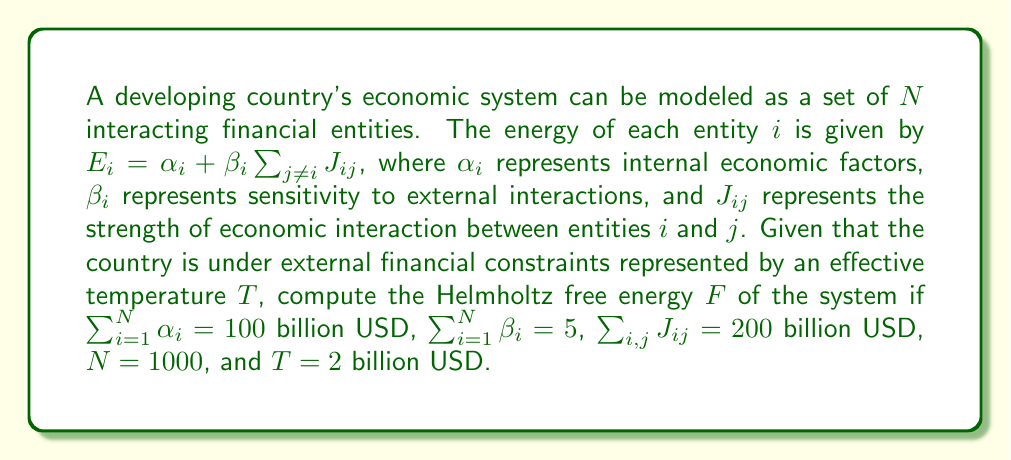Could you help me with this problem? To solve this problem, we'll use the statistical mechanics approach to calculate the Helmholtz free energy. The steps are as follows:

1) The Helmholtz free energy is given by the formula:
   $$F = U - TS$$
   where $U$ is the internal energy, $T$ is the temperature, and $S$ is the entropy.

2) In this case, we can consider the internal energy $U$ as the sum of all entity energies:
   $$U = \sum_{i=1}^N E_i = \sum_{i=1}^N (\alpha_i + \beta_i \sum_{j \neq i} J_{ij})$$

3) Simplifying this expression:
   $$U = \sum_{i=1}^N \alpha_i + \sum_{i=1}^N \beta_i \sum_{j \neq i} J_{ij}$$

4) We're given that $\sum_{i=1}^N \alpha_i = 100$ billion USD and $\sum_{i,j} J_{ij} = 200$ billion USD. 
   Note that $\sum_{i,j} J_{ij}$ includes self-interactions, so we need to subtract these:
   $$\sum_{i=1}^N \sum_{j \neq i} J_{ij} = \sum_{i,j} J_{ij} - \sum_{i} J_{ii} = 200 - 0 = 200$$ billion USD

5) Therefore:
   $$U = 100 + 5 * 200 = 1100$$ billion USD

6) For the entropy term, we can use the Boltzmann formula:
   $$S = k_B \ln \Omega$$
   where $k_B$ is Boltzmann's constant (which we'll take as 1 for simplicity) and $\Omega$ is the number of microstates.

7) In this economic system, we can estimate $\Omega$ as the number of ways to distribute the total energy among $N$ entities:
   $$\Omega \approx \binom{U + N - 1}{N - 1} \approx \frac{(U + N - 1)!}{U!(N-1)!}$$

8) Substituting the values:
   $$S = \ln \frac{(1100 + 1000 - 1)!}{1100!(1000-1)!} \approx 7.90$$

9) Now we can calculate the free energy:
   $$F = U - TS = 1100 - 2 * 7.90 = 1084.20$$ billion USD
Answer: $1084.20$ billion USD 